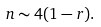<formula> <loc_0><loc_0><loc_500><loc_500>n \sim 4 ( 1 - r ) .</formula> 